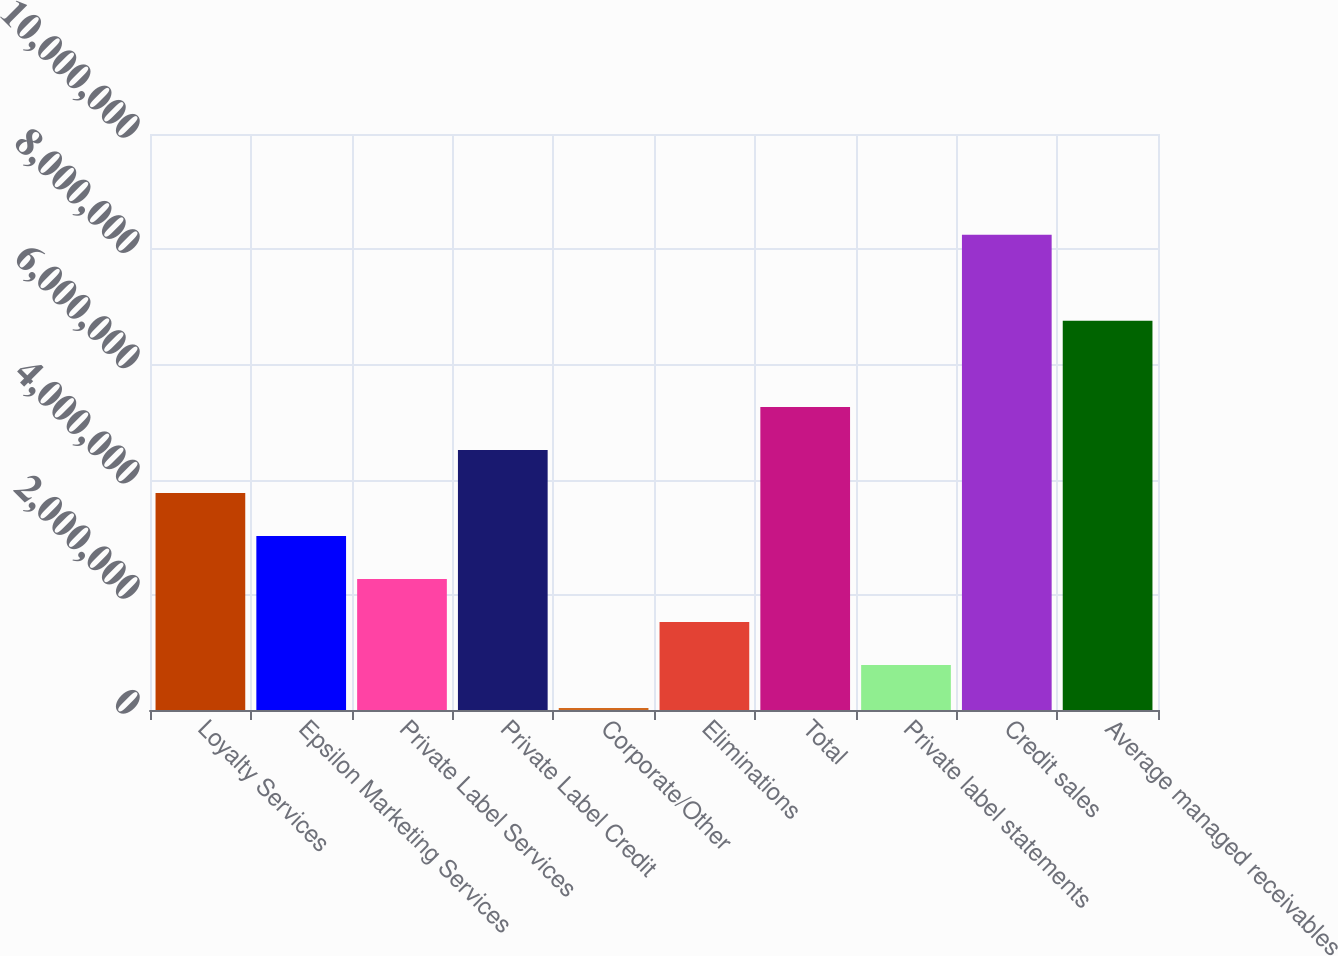Convert chart. <chart><loc_0><loc_0><loc_500><loc_500><bar_chart><fcel>Loyalty Services<fcel>Epsilon Marketing Services<fcel>Private Label Services<fcel>Private Label Credit<fcel>Corporate/Other<fcel>Eliminations<fcel>Total<fcel>Private label statements<fcel>Credit sales<fcel>Average managed receivables<nl><fcel>3.76815e+06<fcel>3.02119e+06<fcel>2.27424e+06<fcel>4.51511e+06<fcel>33360<fcel>1.52728e+06<fcel>5.26207e+06<fcel>780319<fcel>8.24991e+06<fcel>6.75599e+06<nl></chart> 